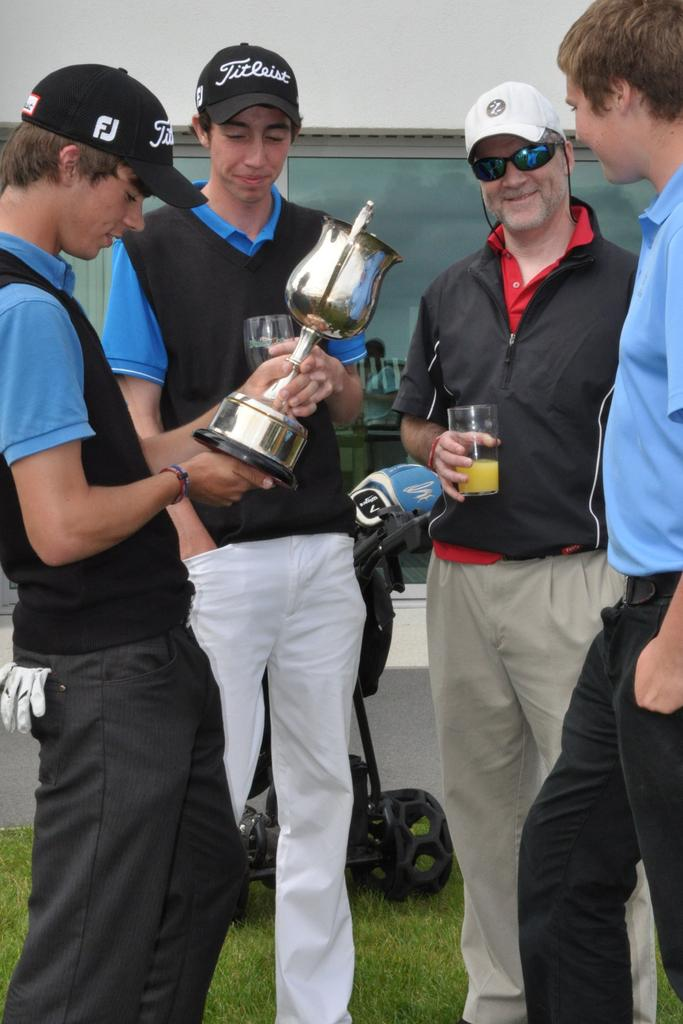<image>
Write a terse but informative summary of the picture. the boy holding the trophy is wearing an FJ hat 